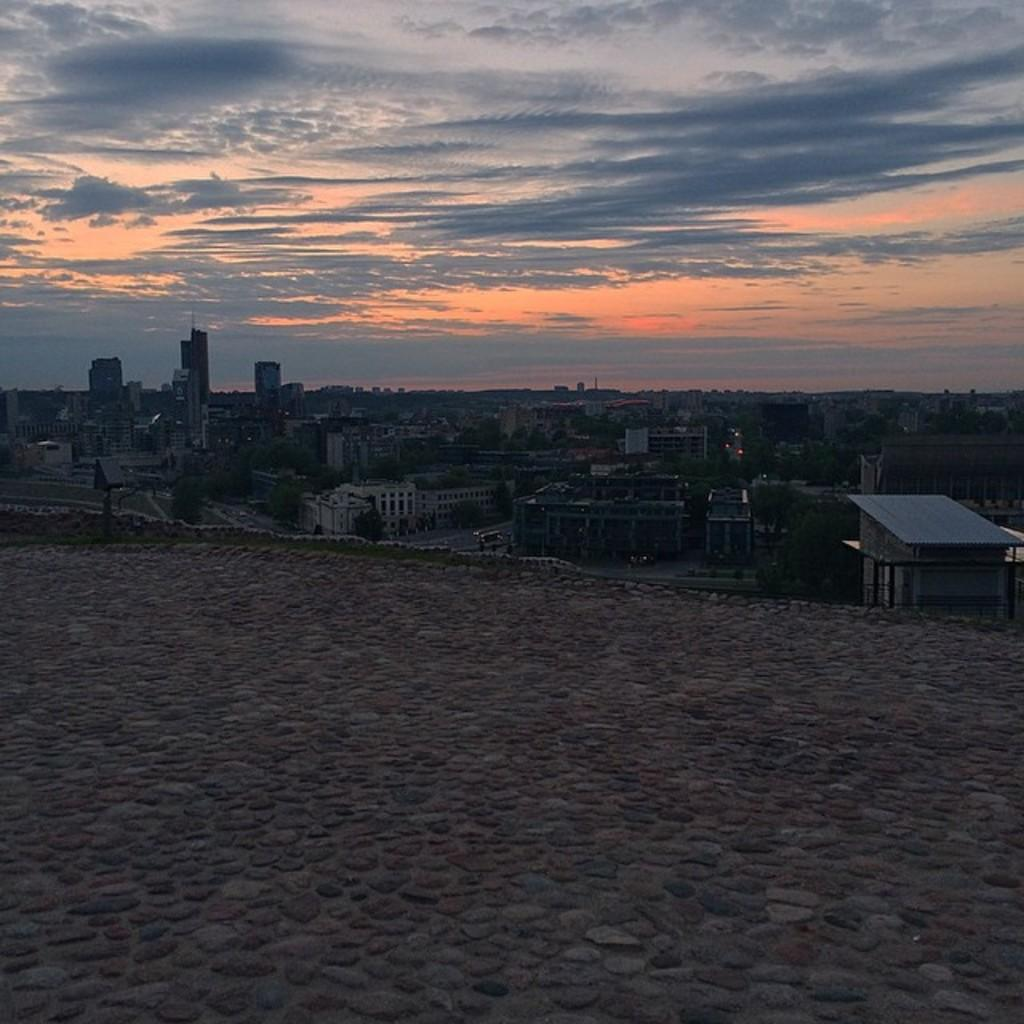What type of structures can be seen in the image? There are buildings in the image. What other natural elements are present in the image? There are trees in the image. What mode of transportation can be seen on the road in the image? Motor vehicles are present on the road in the image. What is visible in the background of the image? The sky is visible in the image. What is the condition of the sky in the image? There are clouds in the sky. Can you tell me how many pets are visible in the image? There are no pets present in the image. What type of sheet is covering the buildings in the image? There is no sheet covering the buildings in the image; they are visible as they are. 